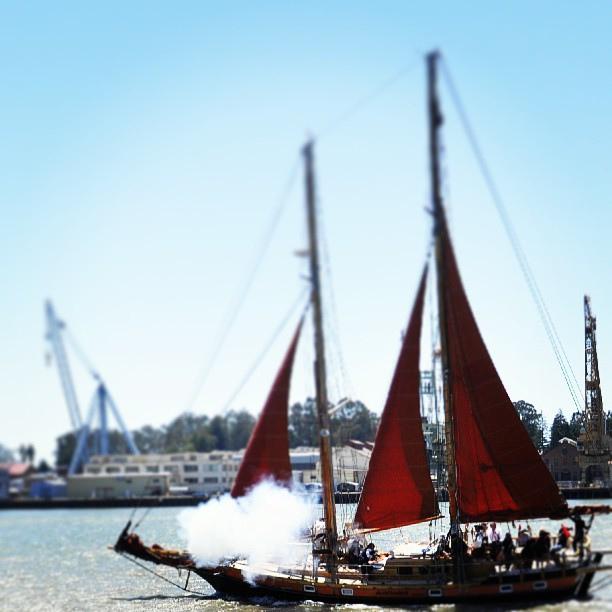What propels the ship forward?
Concise answer only. Wind. Is there smoke coming from the boat?
Answer briefly. Yes. Where are there no flag on this ship?
Concise answer only. Yes. 